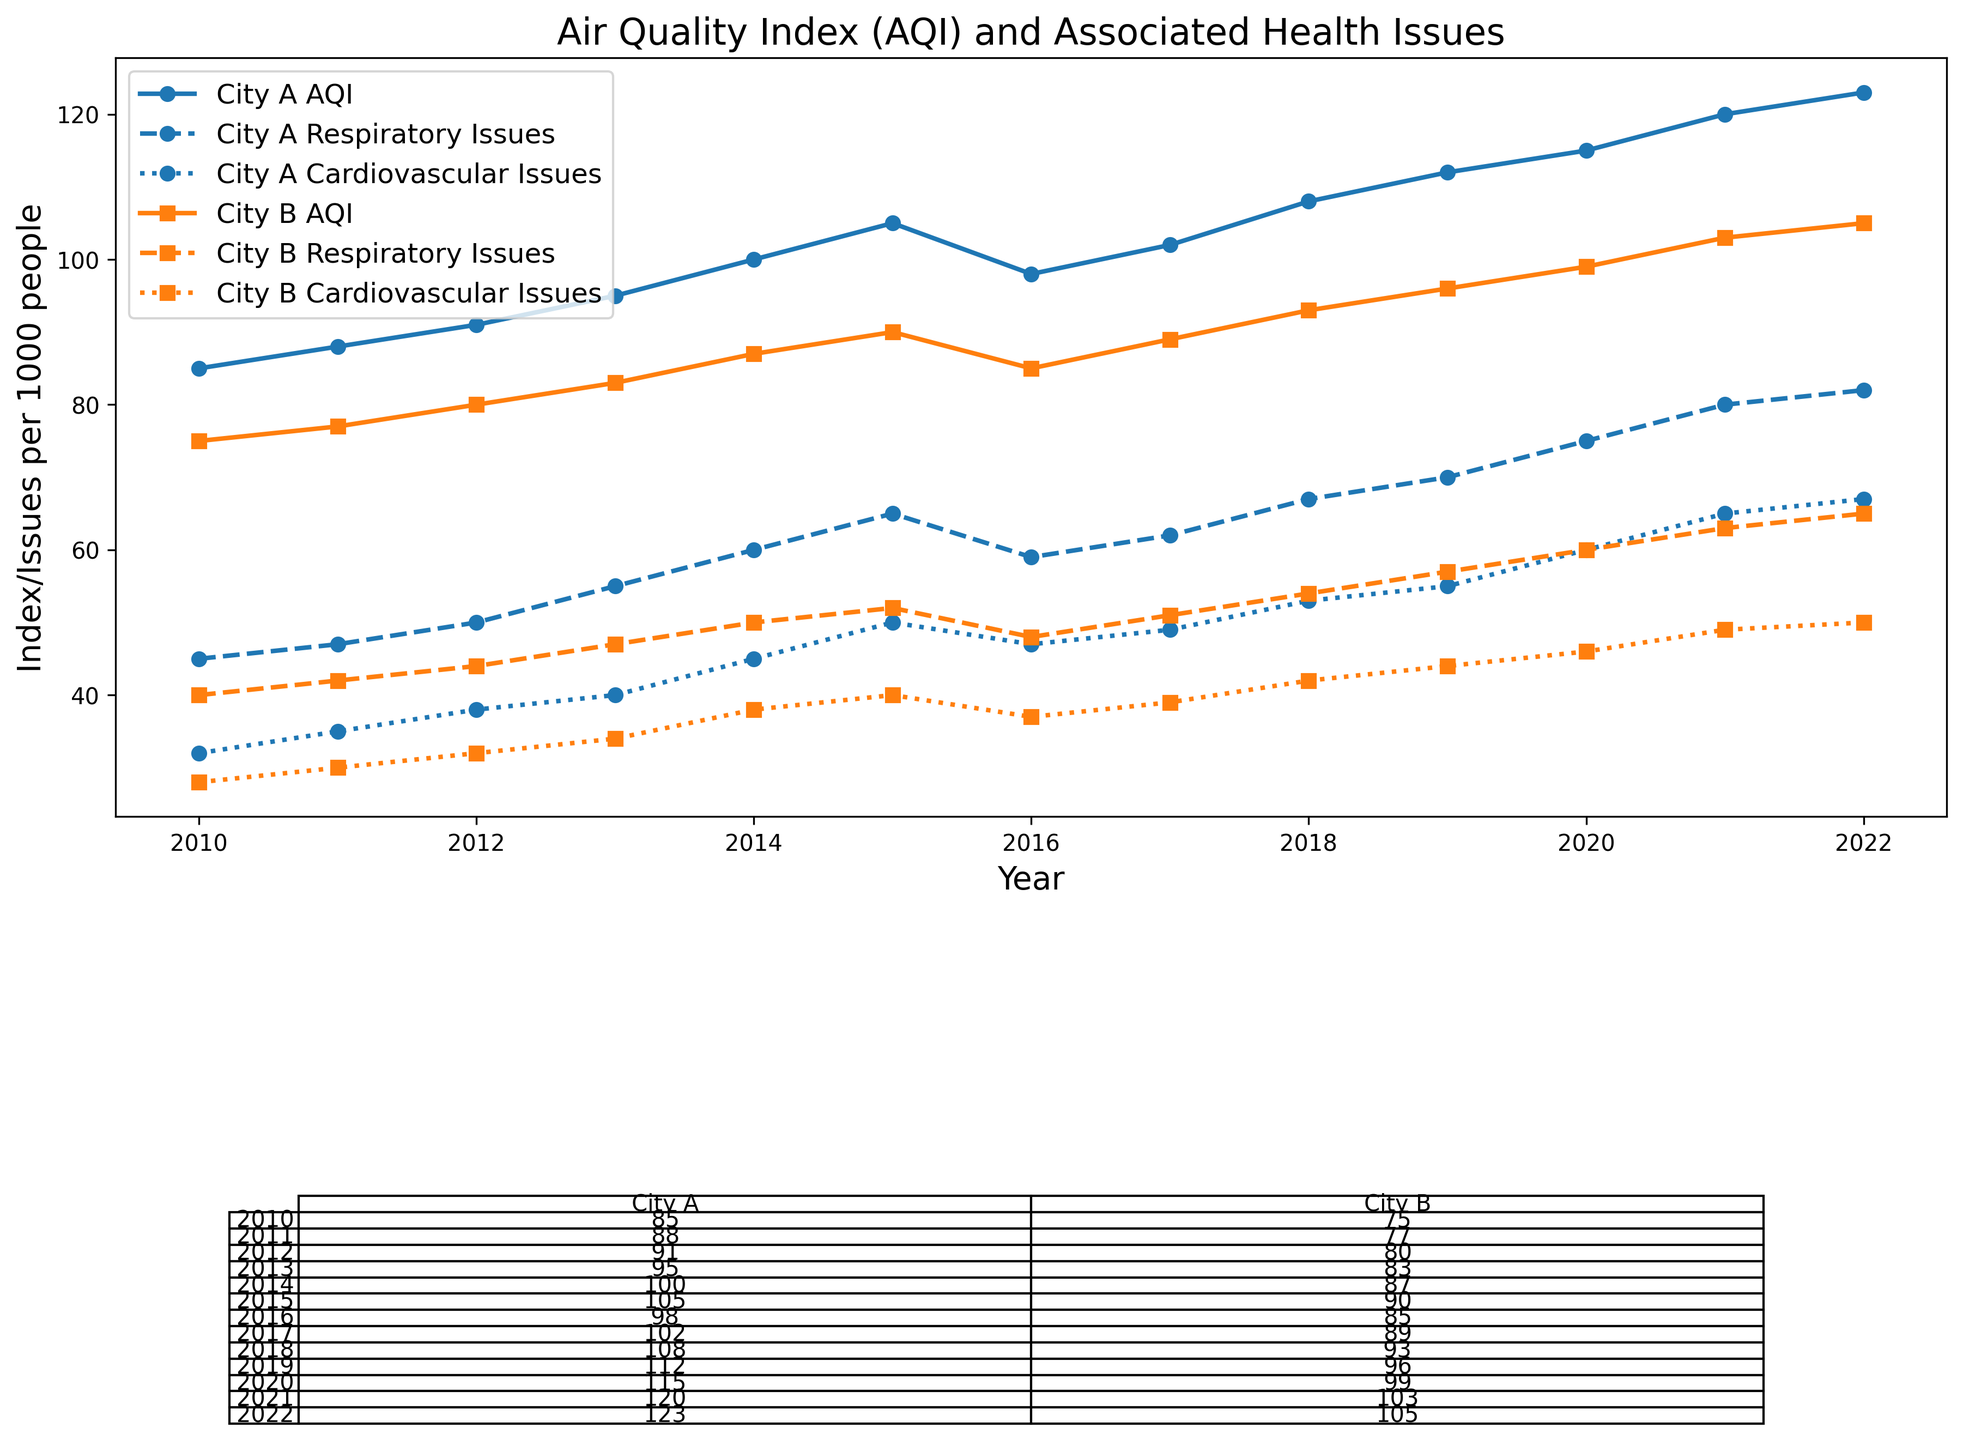How did the Air Quality Index (AQI) in City A change from 2010 to 2022? To find the change in AQI from 2010 to 2022 in City A, subtract the AQI value in 2010 (85) from the AQI value in 2022 (123). The change is 123 - 85 = 38.
Answer: 38 Which city had a higher Respiratory Issues rate in 2021, City A or City B? To determine which city had a higher Respiratory Issues rate in 2021, compare the values for Respiratory Issues in the respective cities in the table. City A had 80 cases per 1000 people and City B had 63. Therefore, City A had a higher rate.
Answer: City A What was the trend in Cardiovascular Issues in City B from 2015 to 2022? To identify the trend, observe the values from 2015 to 2022 for Cardiovascular Issues in City B. The values are: 40, 37, 39, 42, 44, 46, 49, and 50, which shows an overall increasing trend with a slight dip in 2016.
Answer: Increasing trend Is there a notable relationship between AQI and Respiratory Issues in both cities? Examine the plots and values for AQI and Respiratory Issues together. In both cities, as AQI rises, Respiratory Issues also increase, which suggests a positive correlation between them.
Answer: Positive correlation On average, how much did the Cardiovascular Issues increase per year in City A between 2010 and 2022? To calculate the average annual increase, first find the total increase and then divide by the number of years. The increase in Cardiovascular Issues from 2010 to 2022 in City A is 67 - 32 = 35. This increase occurred over 12 years, so the average annual increase is 35 / 12 ≈ 2.92 per year.
Answer: ≈ 2.92 per year If AQI continues to rise at the same rate as it did from 2020 to 2022 in City A, what would be the projected AQI in 2025? To determine this, first find the annual increase from 2020 (115) to 2022 (123). The increase is 123 - 115 = 8 over 2 years, so the annual increase is 8 / 2 = 4. For three more years (2022 to 2025), the projected increase is 4 * 3 = 12. Adding this to the 2022 AQI gives 123 + 12 = 135.
Answer: 135 Which city had a higher AQI in 2018, and by how much was it higher? Compare the AQI values for both cities in 2018. City A had an AQI of 108, and City B had an AQI of 93. The difference is 108 - 93 = 15.
Answer: City A; 15 How does the amount of Cardiovascular Issues in 2022 compare between City A and City B? To compare, check the values for Cardiovascular Issues in 2022 for both cities. City A has 67 cases, and City B has 50. Therefore, City A has more by 67 - 50 = 17 cases.
Answer: City A What is the ratio of Respiratory Issues to Population in City B for the year 2020? To find the ratio, divide the number of Respiratory Issues by the Population and then multiply by 1000 (since population is in thousands). Respiratory Issues are 60 per 1000 people, and Population is 1300 thousands, so the ratio is 60 / 1300 ≈ 0.046 or 46 per 100,000.
Answer: 46 per 100,000 